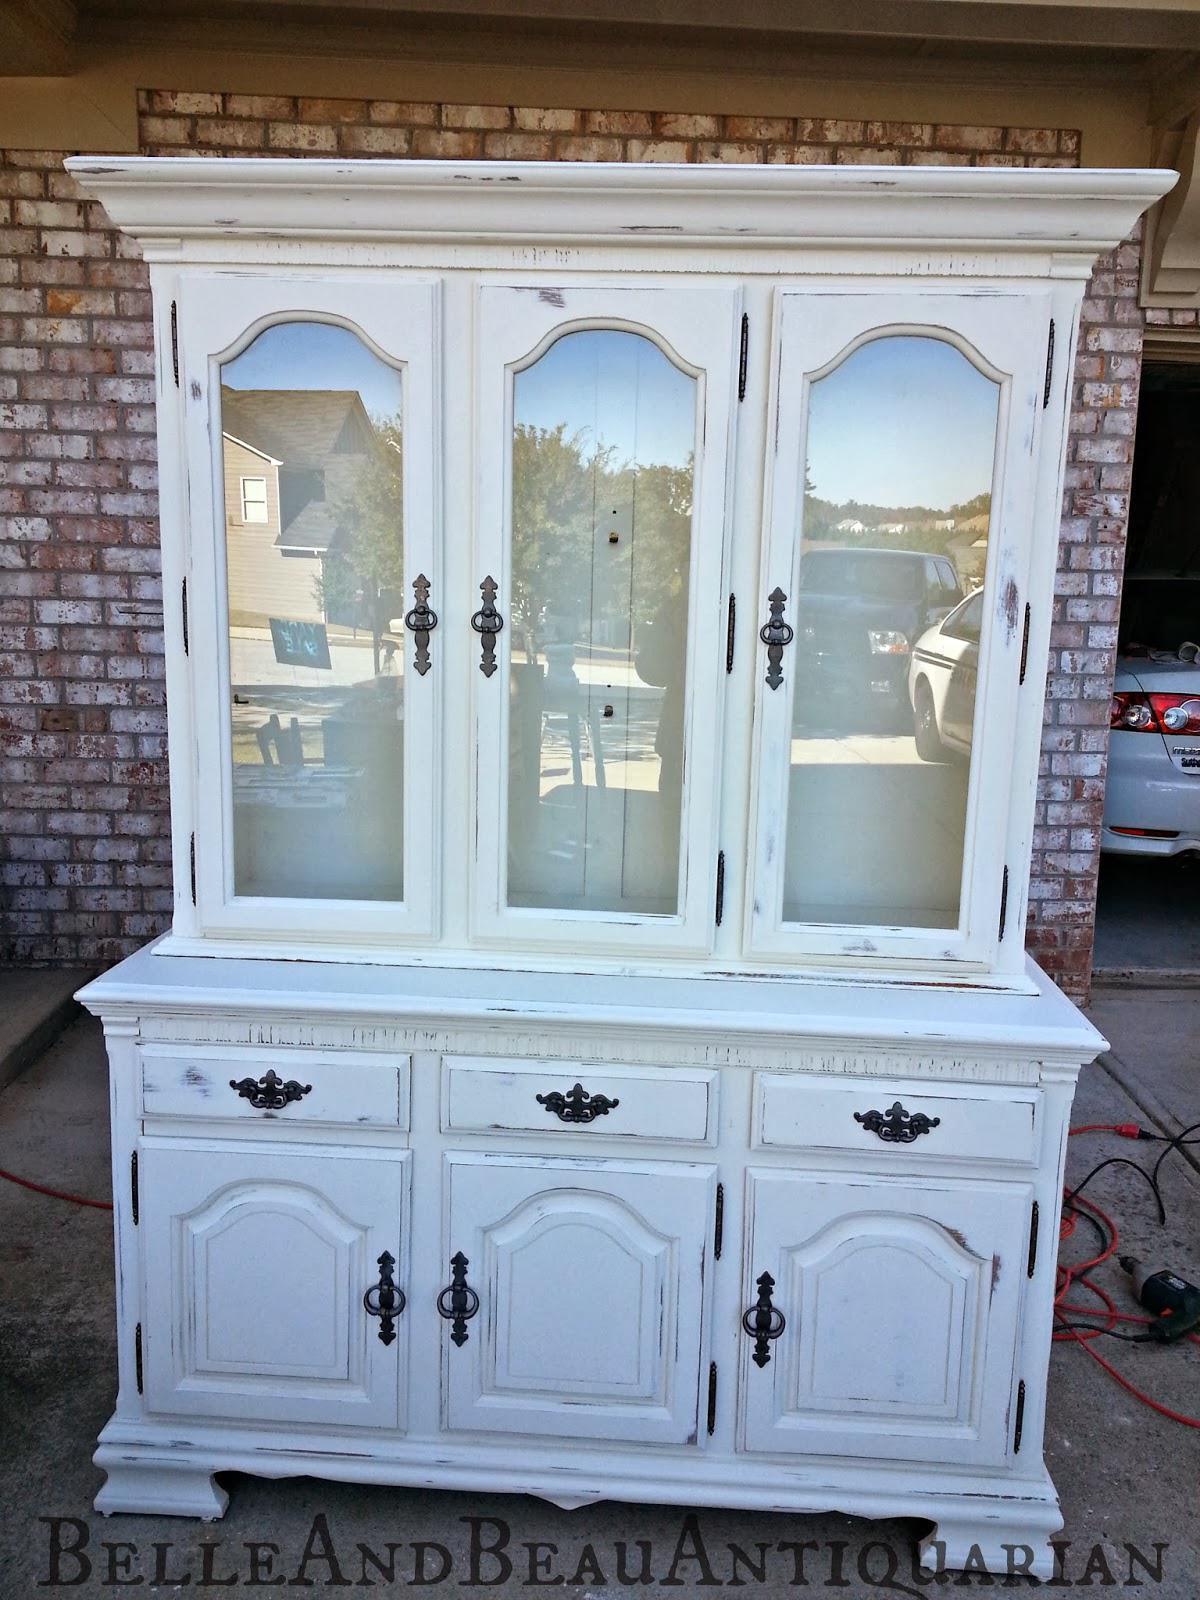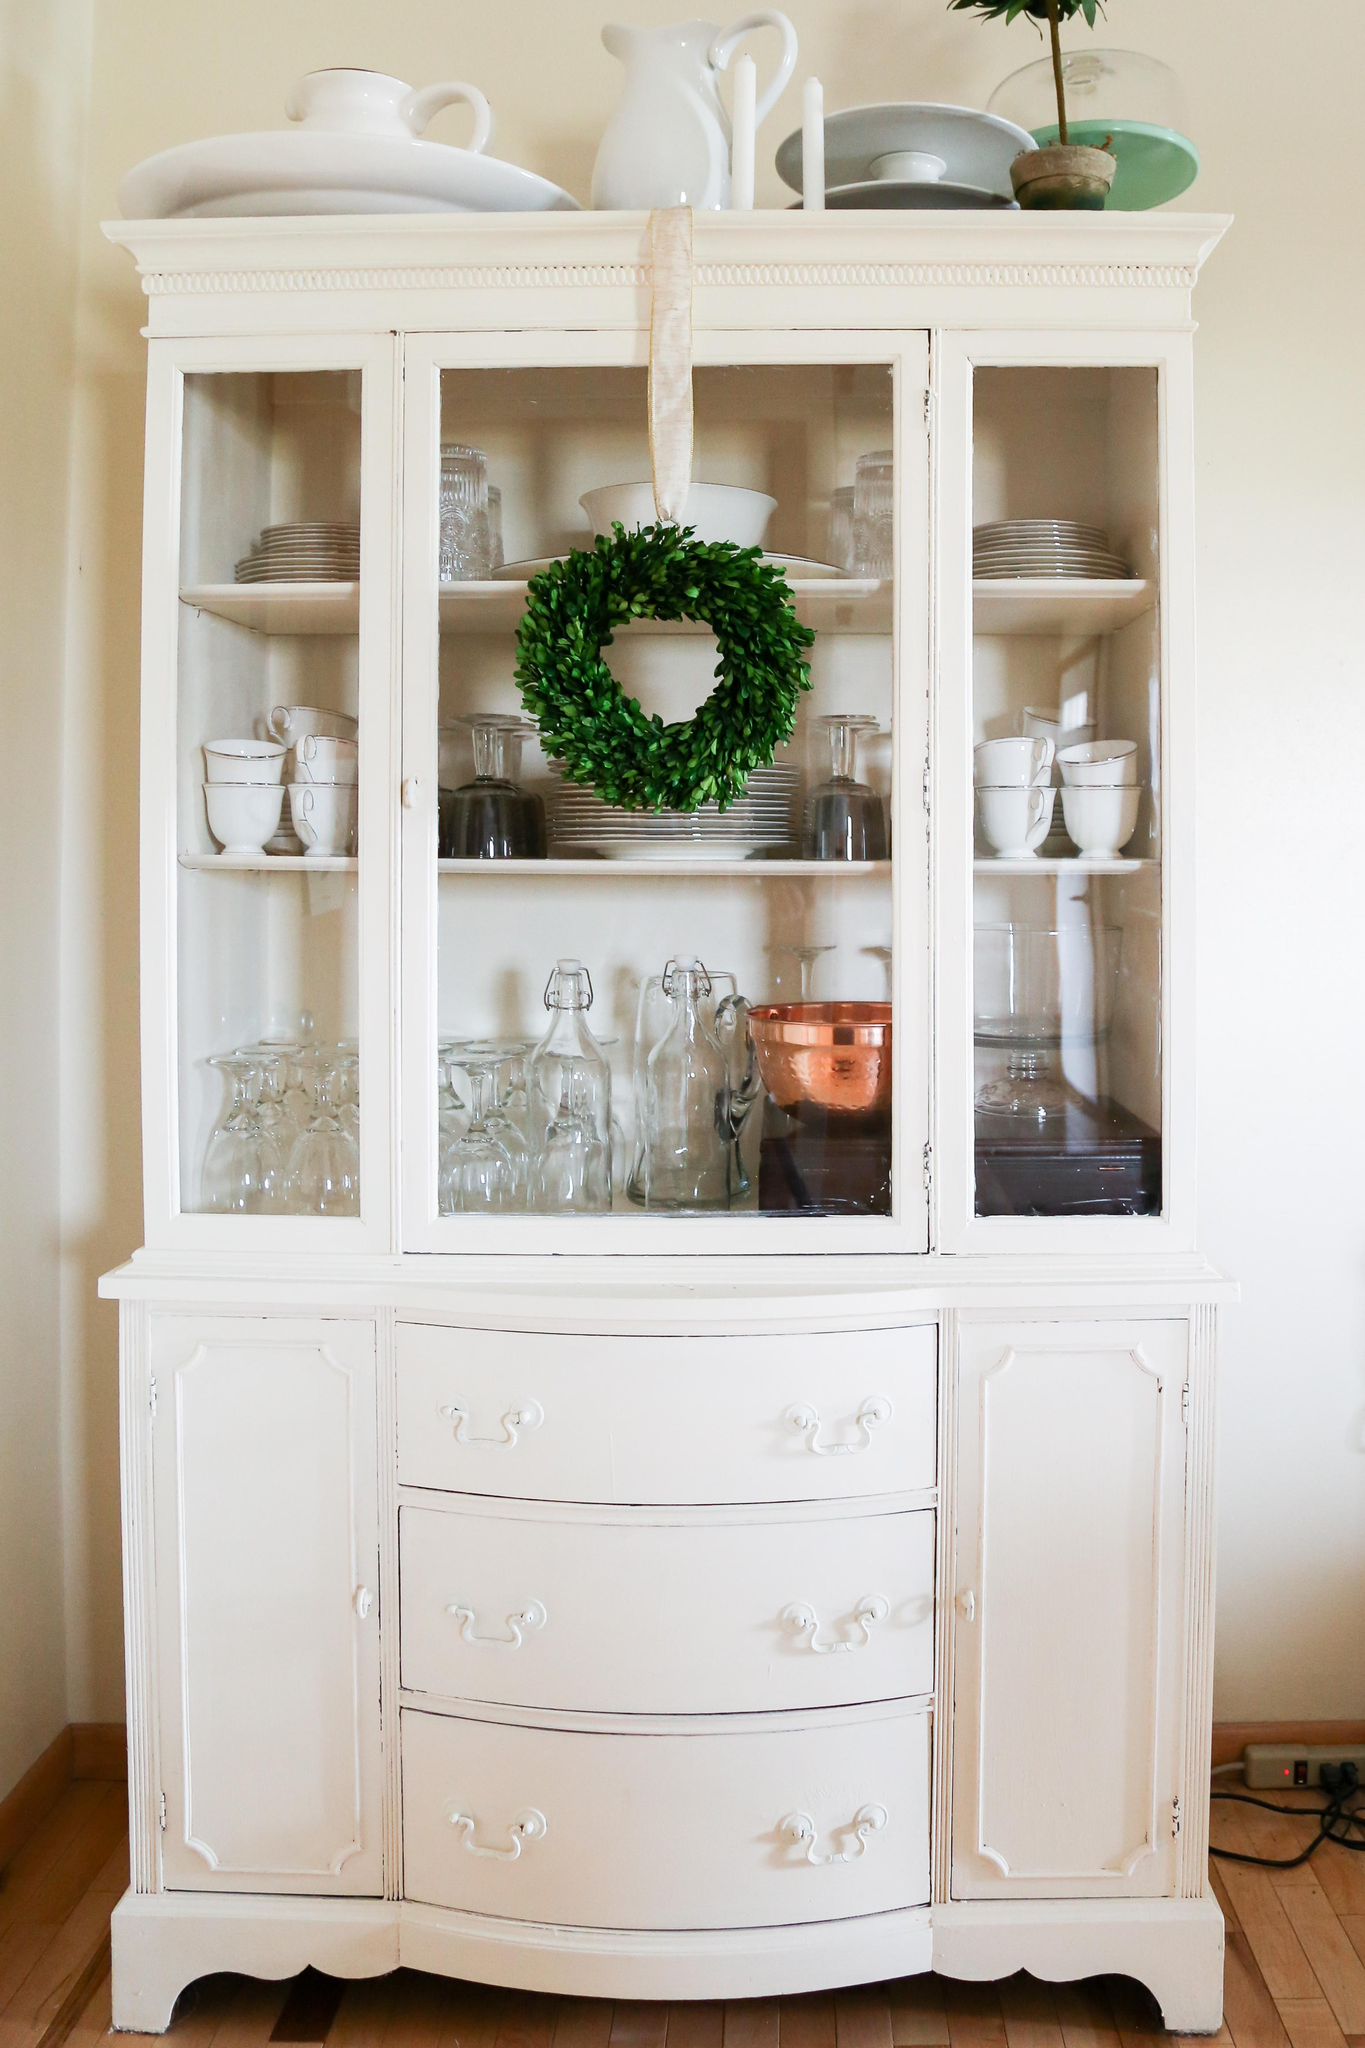The first image is the image on the left, the second image is the image on the right. Analyze the images presented: Is the assertion "A wreath is hanging on a white china cabinet." valid? Answer yes or no. Yes. The first image is the image on the left, the second image is the image on the right. Given the left and right images, does the statement "The right image has a cabinet with a green wreath hanging on it." hold true? Answer yes or no. Yes. 